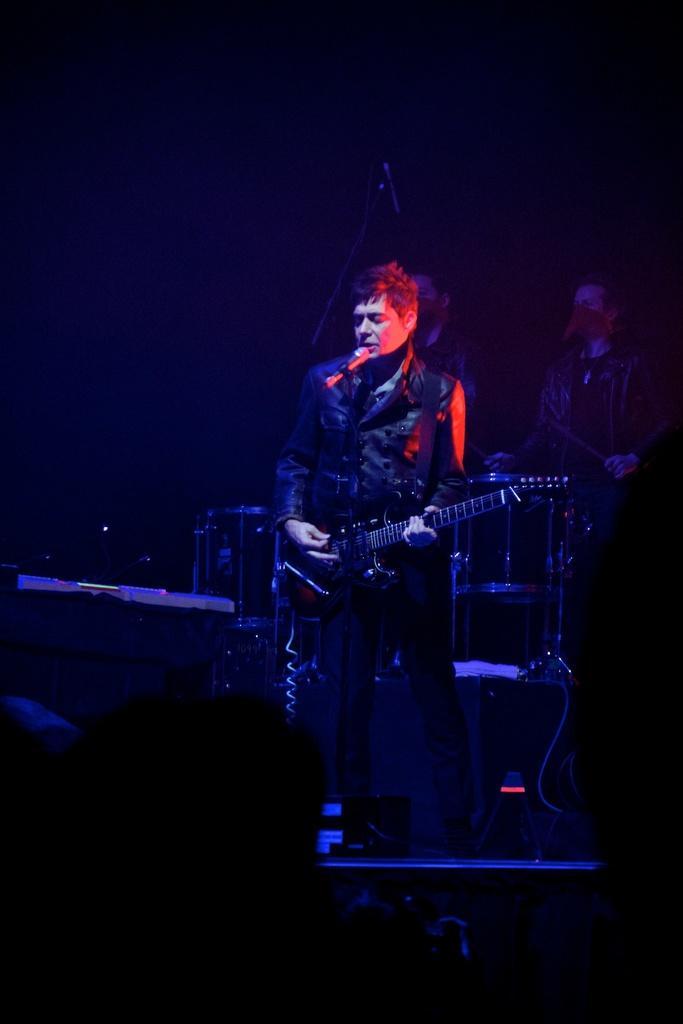In one or two sentences, can you explain what this image depicts? Here I can see a man standing on the stage and playing a guitar. In front of him there is a mike stand. In the background there is a person playing the drums. The background is dark. 